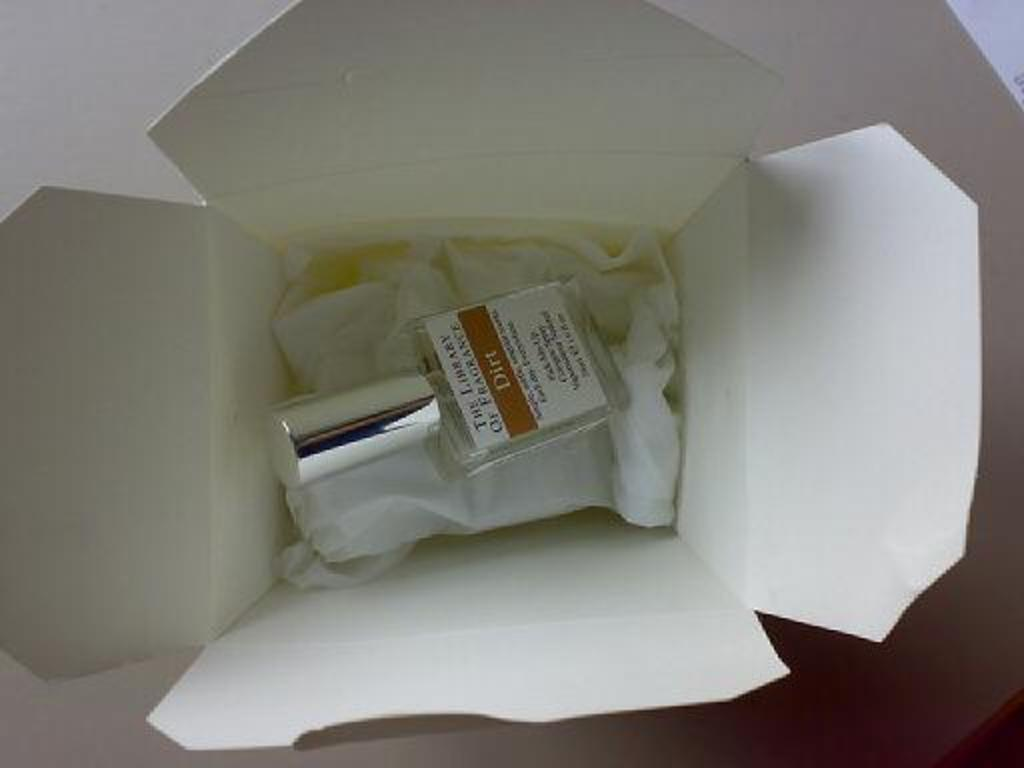Provide a one-sentence caption for the provided image. A bottle of Dirt scented perfume is in a white Chinese takeout box. 